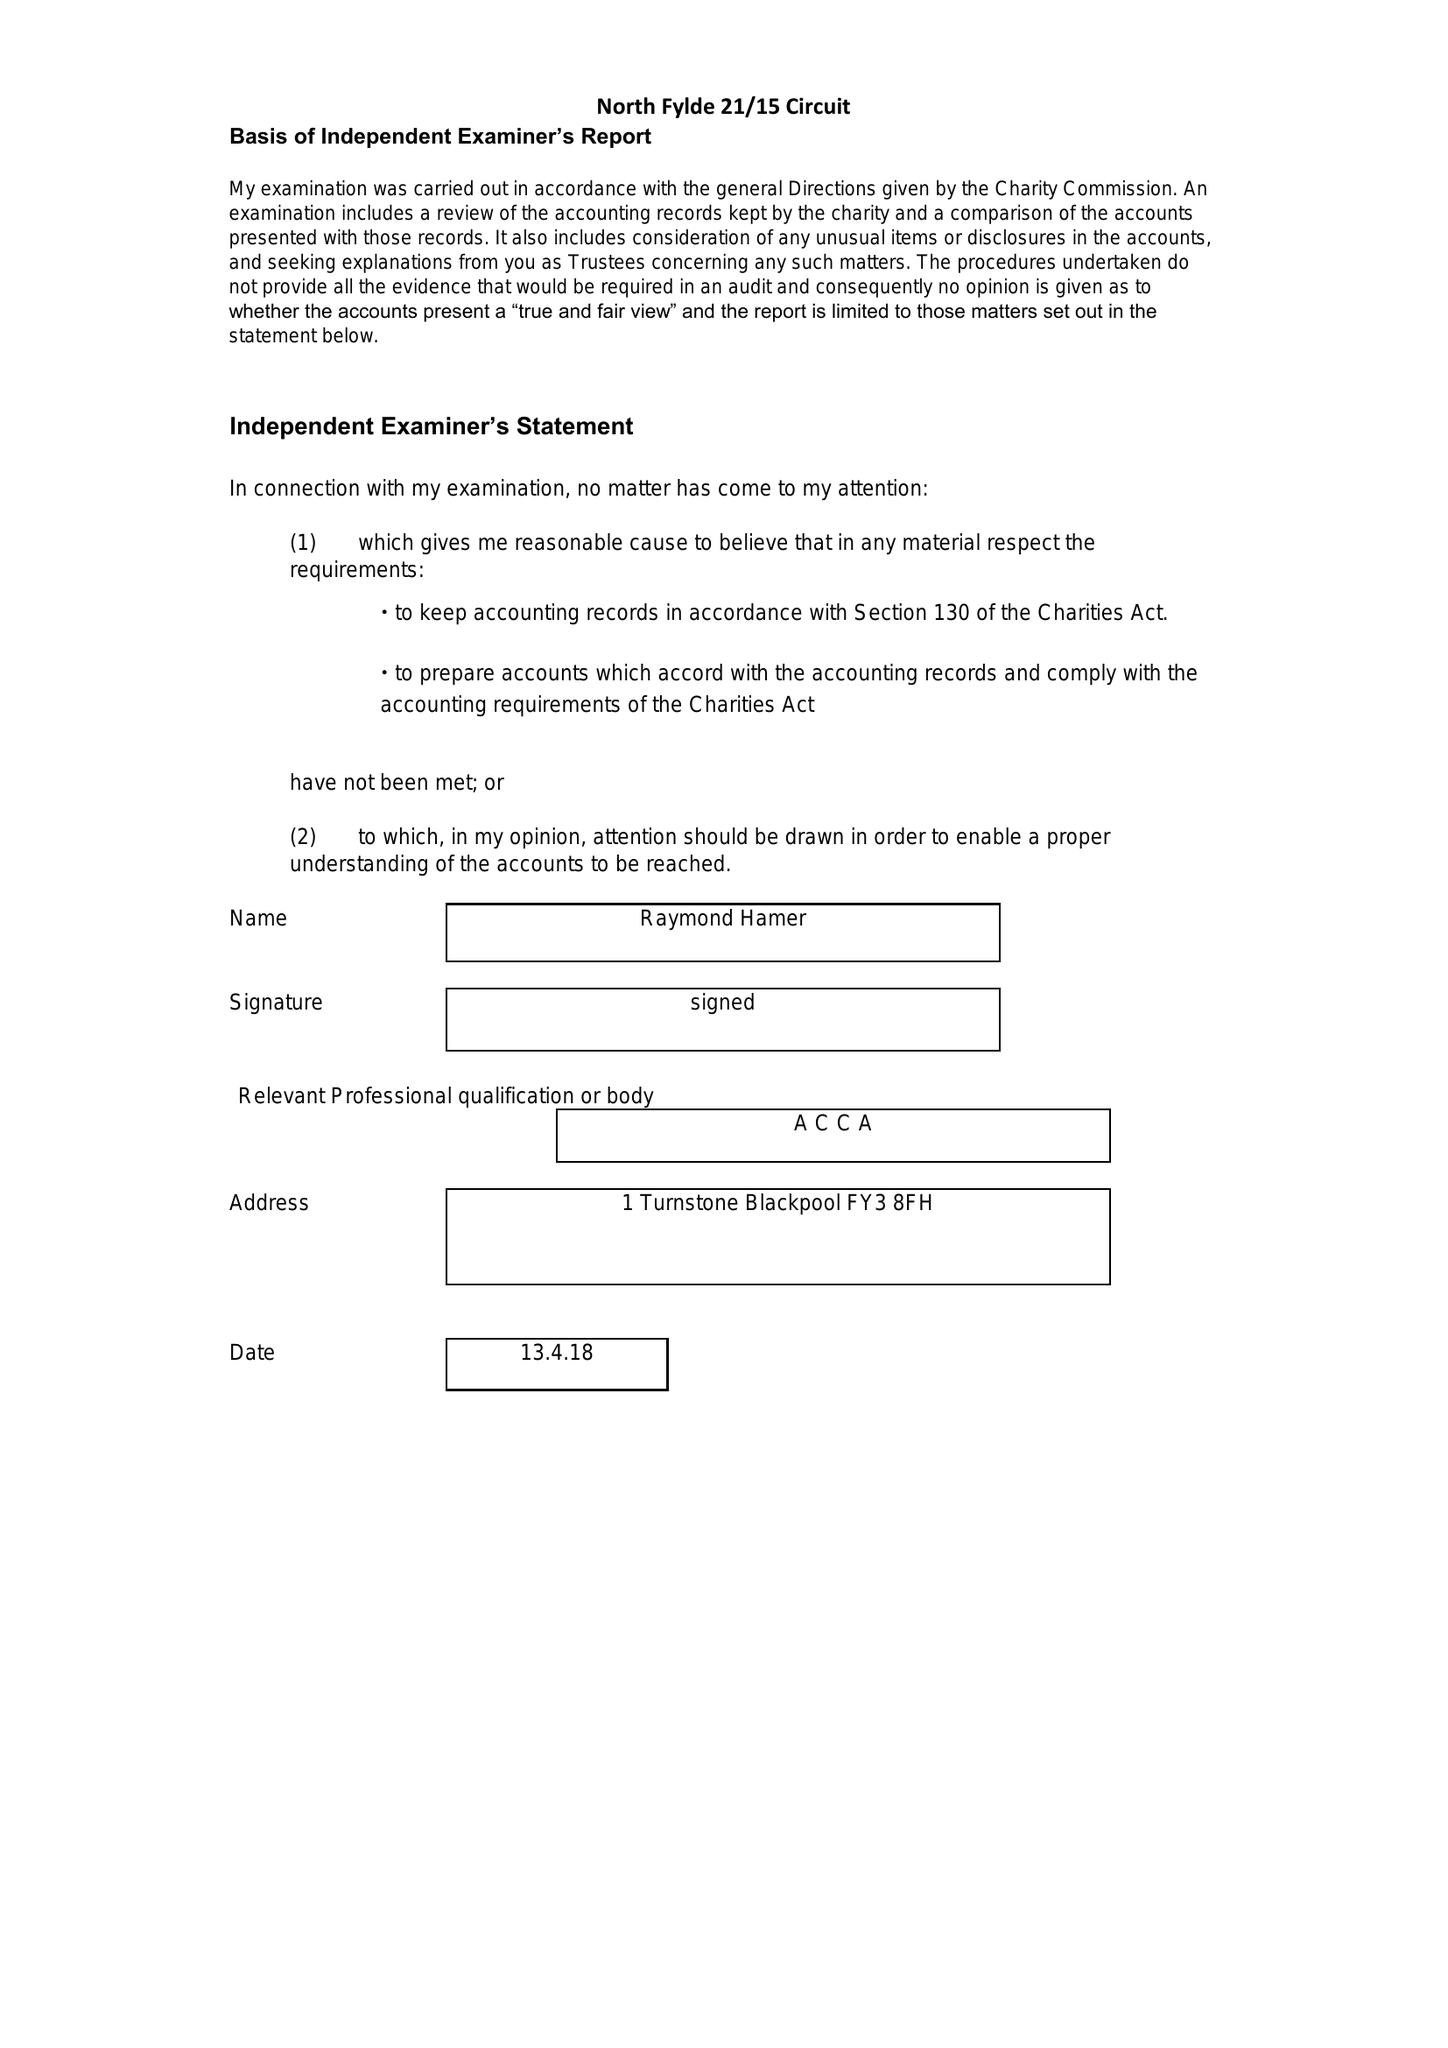What is the value for the address__postcode?
Answer the question using a single word or phrase. FY6 7RE 